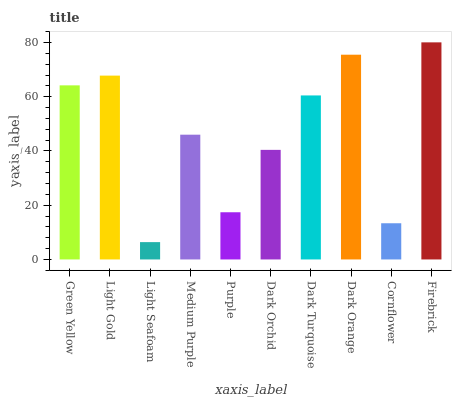Is Light Seafoam the minimum?
Answer yes or no. Yes. Is Firebrick the maximum?
Answer yes or no. Yes. Is Light Gold the minimum?
Answer yes or no. No. Is Light Gold the maximum?
Answer yes or no. No. Is Light Gold greater than Green Yellow?
Answer yes or no. Yes. Is Green Yellow less than Light Gold?
Answer yes or no. Yes. Is Green Yellow greater than Light Gold?
Answer yes or no. No. Is Light Gold less than Green Yellow?
Answer yes or no. No. Is Dark Turquoise the high median?
Answer yes or no. Yes. Is Medium Purple the low median?
Answer yes or no. Yes. Is Light Seafoam the high median?
Answer yes or no. No. Is Dark Orchid the low median?
Answer yes or no. No. 